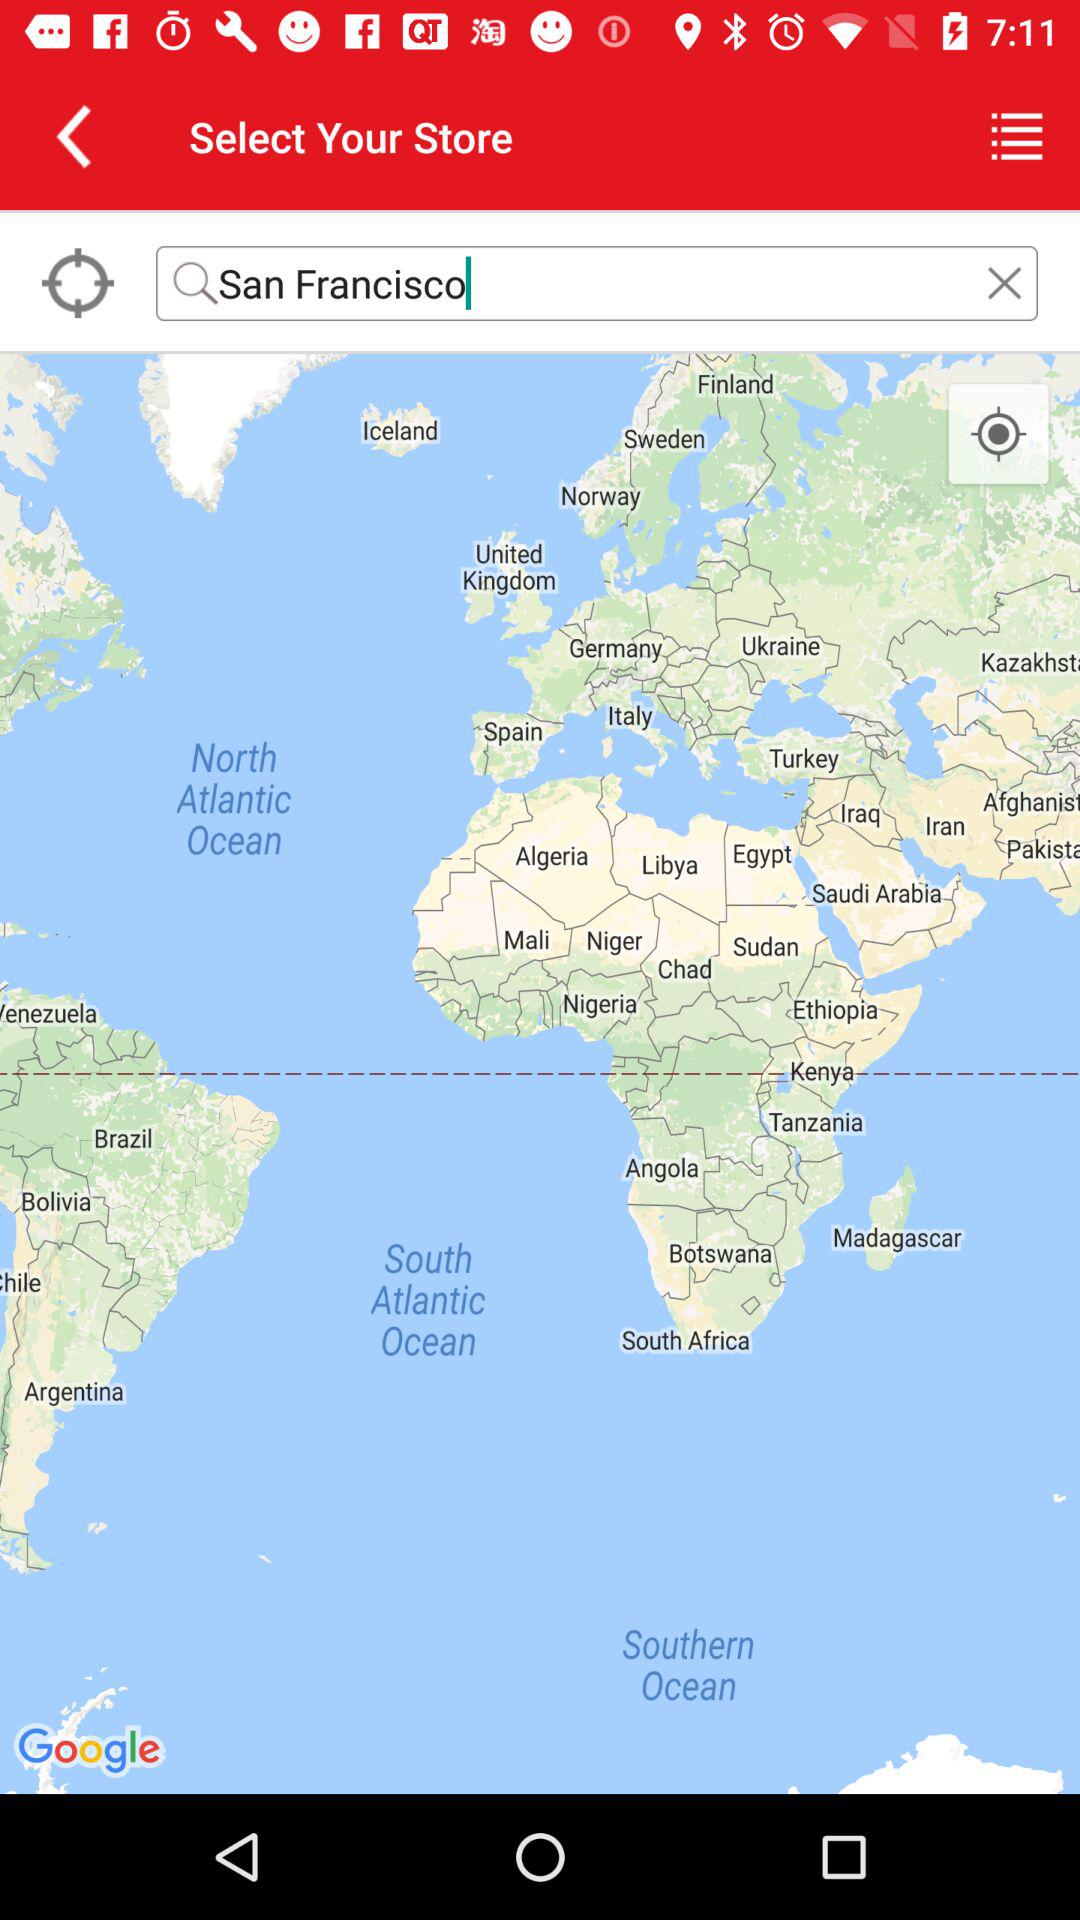What is the input in the search bar? The input in the search bar is "San Francisco". 